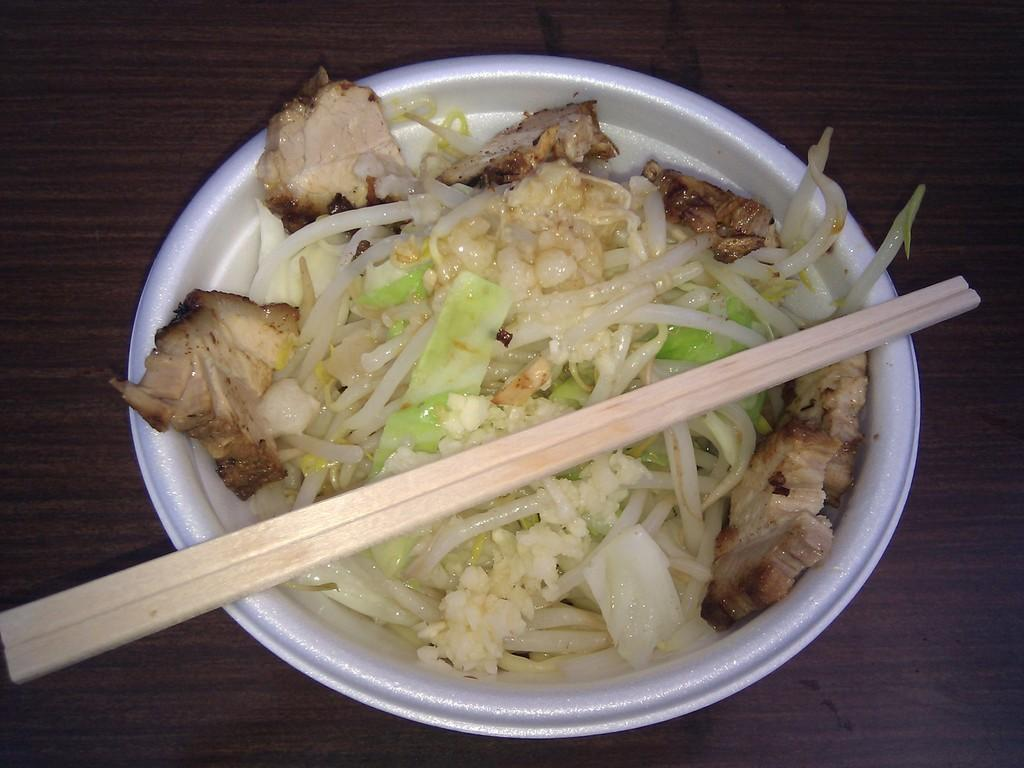What is in the white bowl in the image? There is a closed picture of a food item in a white bowl. What is on top of the bowl? There is a stick on top of the bowl. What is the white ball resting on? The white ball is on a wooden surface. What type of toys can be seen in the image? There are no toys present in the image. What season is depicted in the image? The image does not depict a specific season, such as summer. 